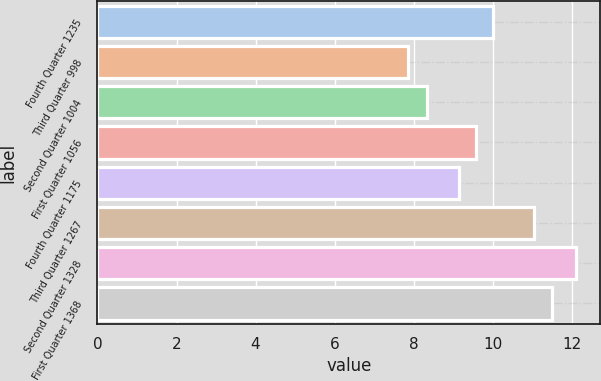Convert chart to OTSL. <chart><loc_0><loc_0><loc_500><loc_500><bar_chart><fcel>Fourth Quarter 1235<fcel>Third Quarter 998<fcel>Second Quarter 1004<fcel>First Quarter 1056<fcel>Fourth Quarter 1175<fcel>Third Quarter 1267<fcel>Second Quarter 1328<fcel>First Quarter 1368<nl><fcel>10<fcel>7.86<fcel>8.35<fcel>9.57<fcel>9.14<fcel>11.04<fcel>12.11<fcel>11.5<nl></chart> 